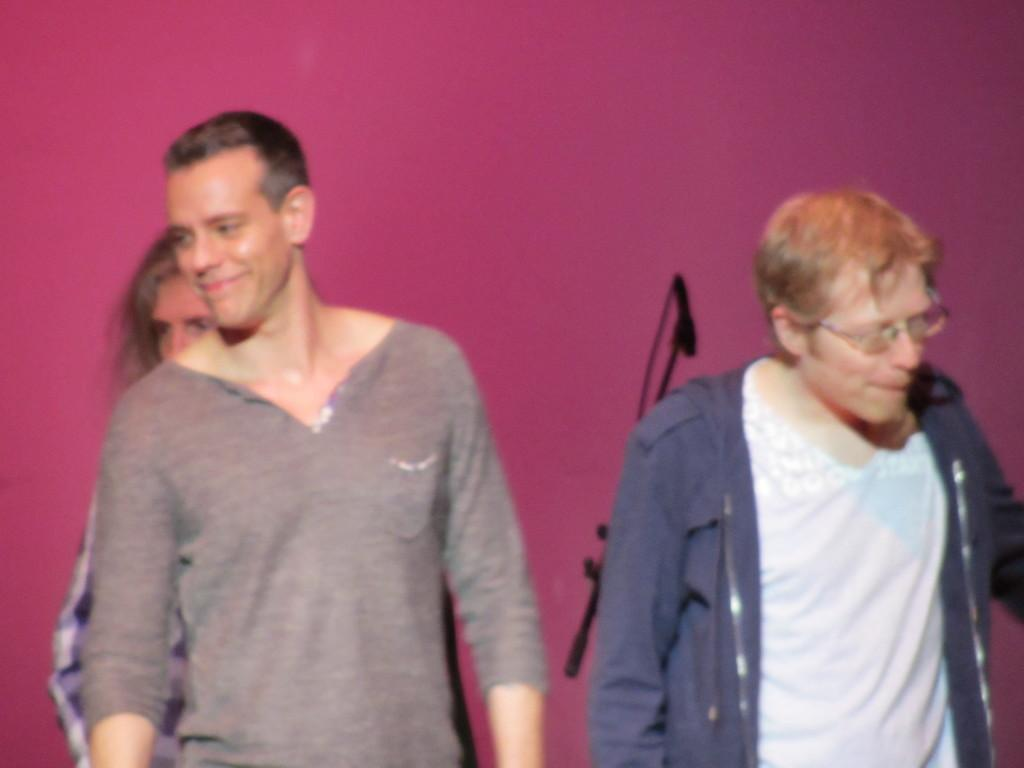How many people are present in the image? There are three people in the image. Can you describe any specific features of one of the people? One of the people is wearing spectacles. What object can be seen in the image that is typically used for amplifying sound? There is a mic stand in the image. What color is the wall visible in the background of the image? There is a pink wall in the background of the image. What type of pie is being served to the people in the image? There is no pie present in the image; it features three people, a mic stand, and a pink wall in the background. 